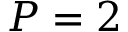<formula> <loc_0><loc_0><loc_500><loc_500>P = 2</formula> 